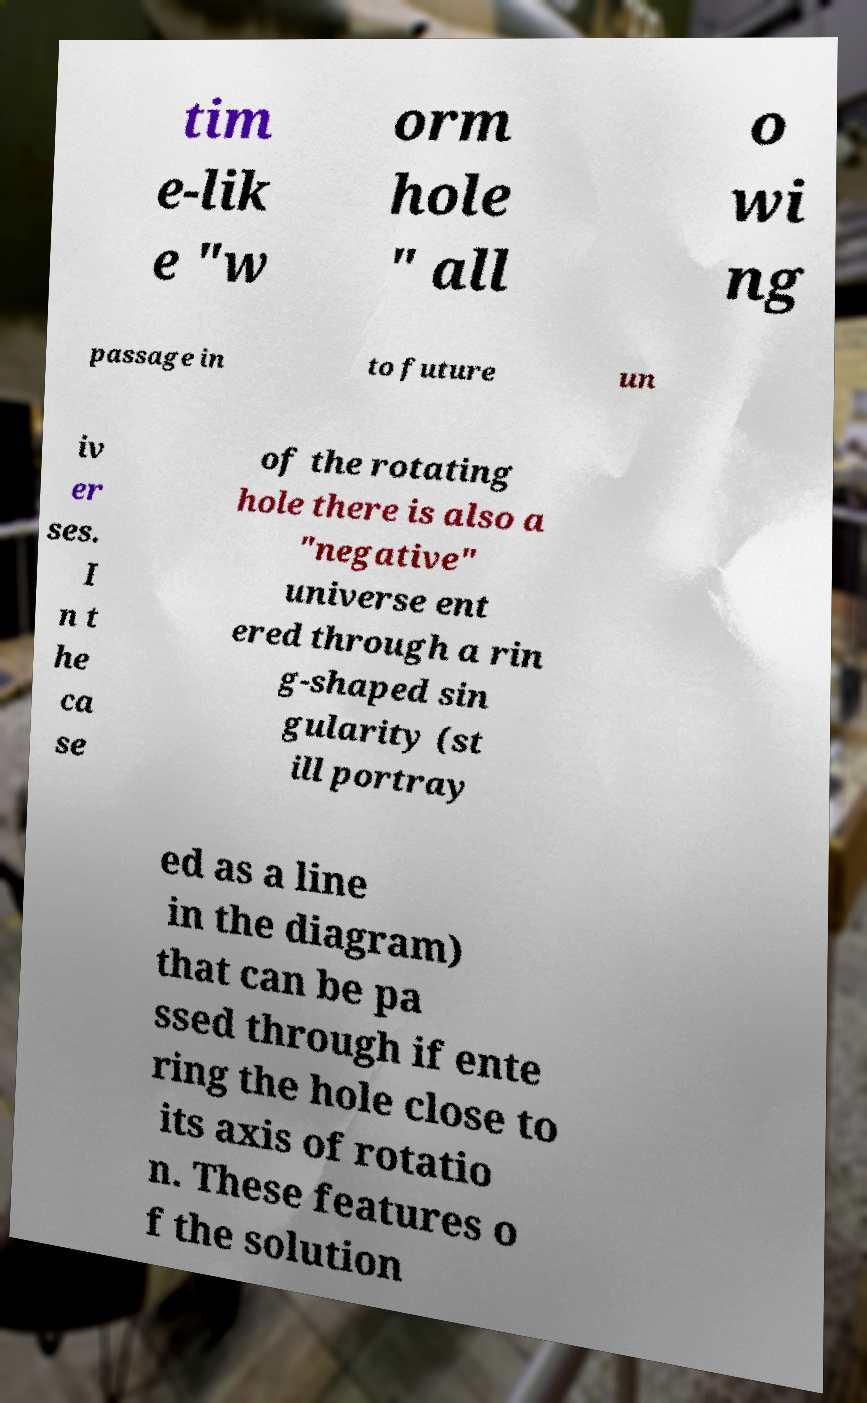For documentation purposes, I need the text within this image transcribed. Could you provide that? tim e-lik e "w orm hole " all o wi ng passage in to future un iv er ses. I n t he ca se of the rotating hole there is also a "negative" universe ent ered through a rin g-shaped sin gularity (st ill portray ed as a line in the diagram) that can be pa ssed through if ente ring the hole close to its axis of rotatio n. These features o f the solution 